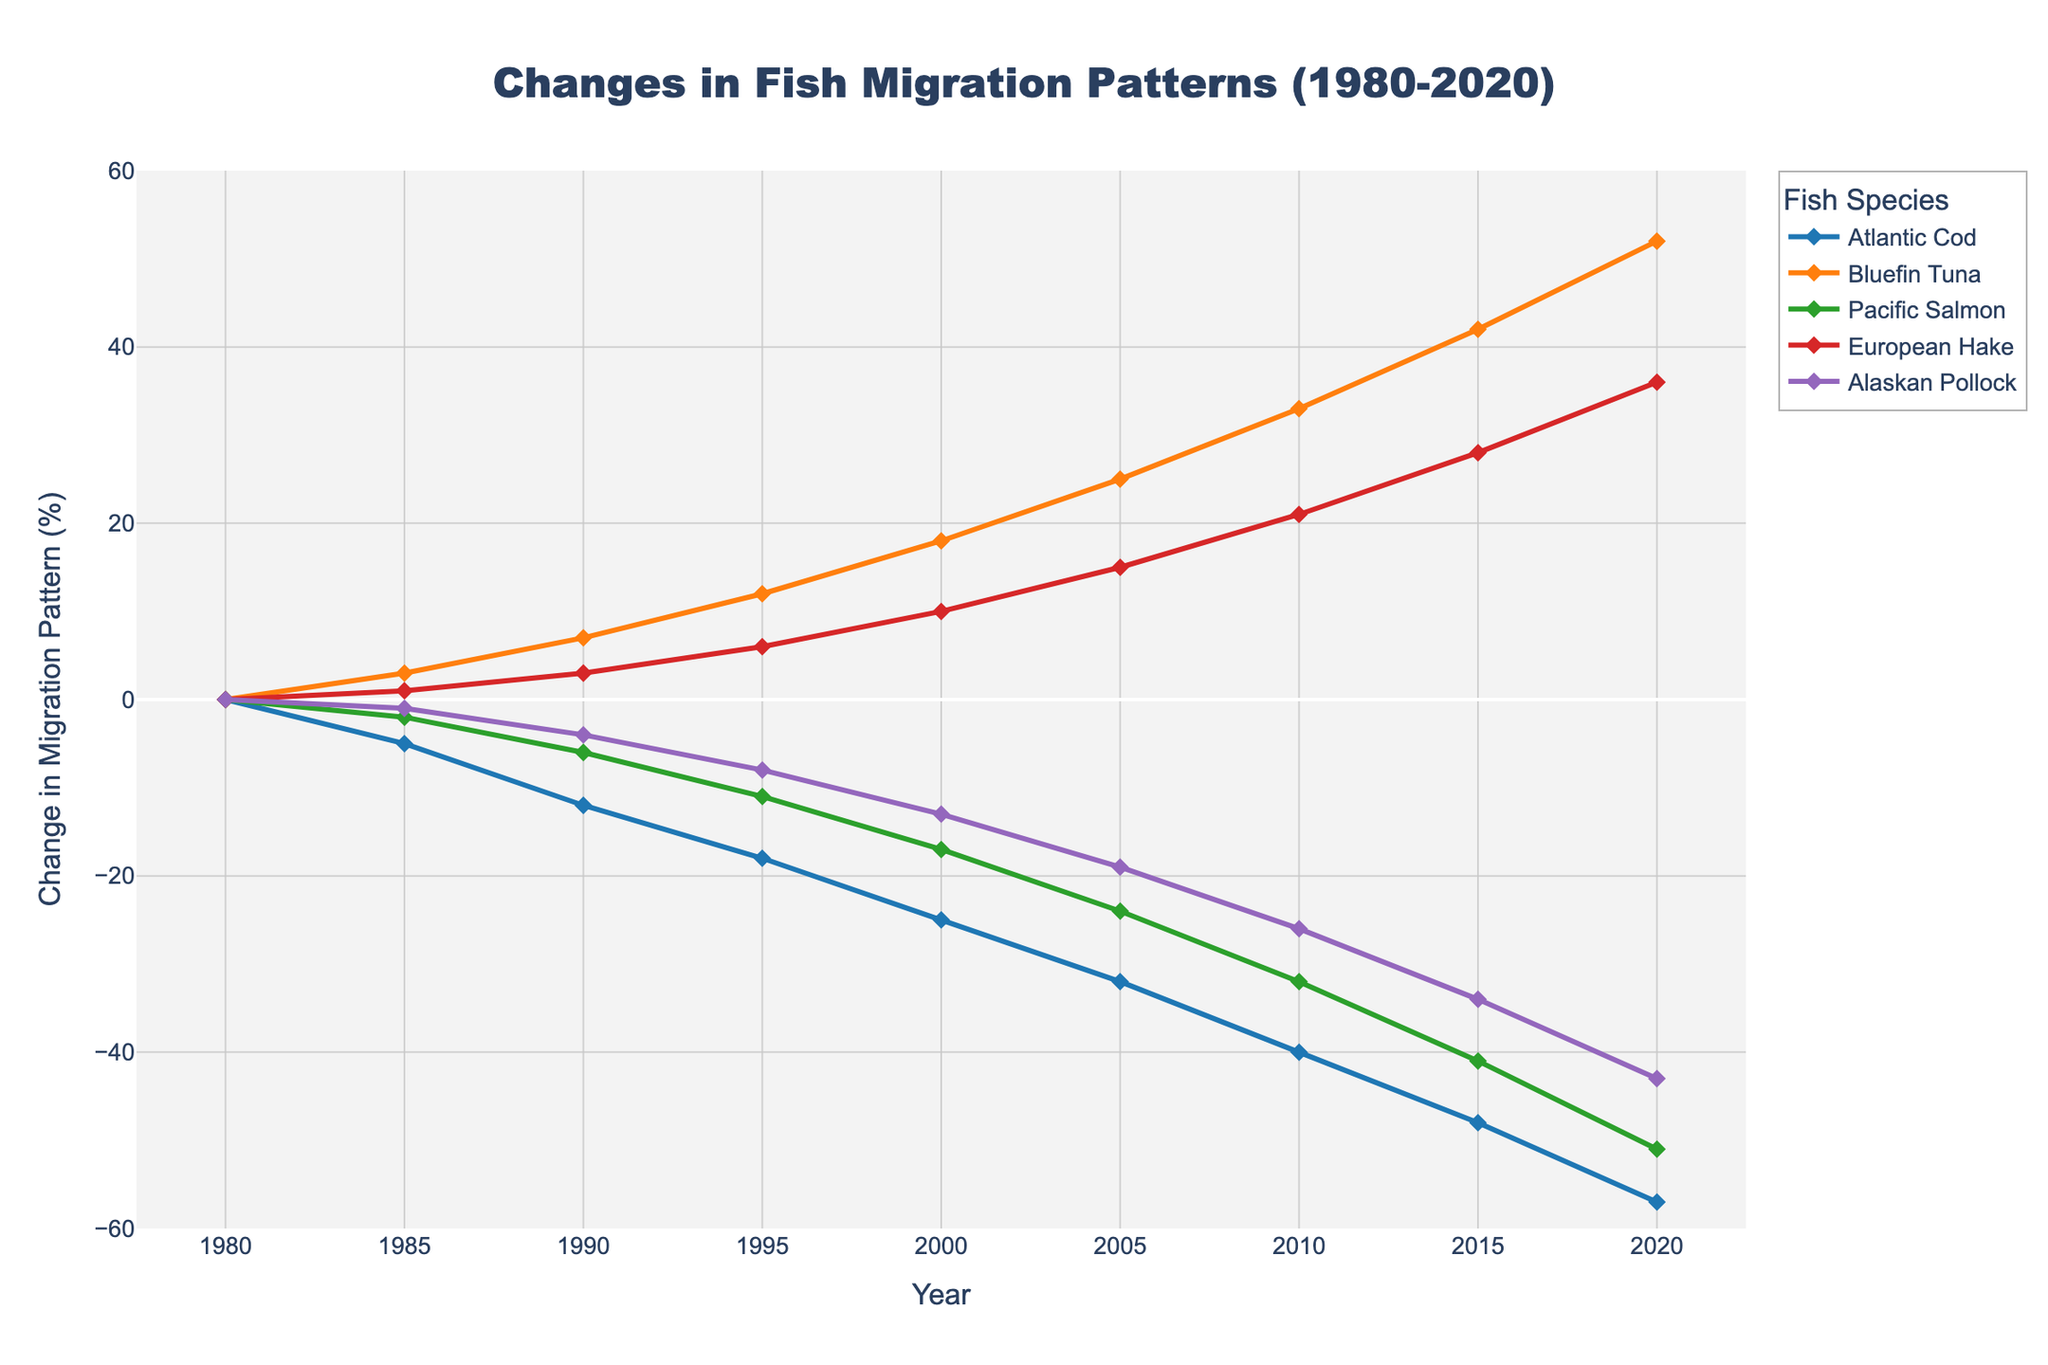Which fish species shows the greatest increase in migration pattern change from 1980 to 2020? Compare the data points of all species in 1980 and 2020. Bluefin Tuna changes from 0 in 1980 to 52 in 2020, which is the highest change.
Answer: Bluefin Tuna By how much did the migration pattern change for Atlantic Cod between 1985 and 2010? Find the data points for Atlantic Cod in 1985 and 2010 (-5 and -40) and subtract them. -40 - (-5) = -35.
Answer: -35 Which species experienced the smallest migration pattern change in 2000? Compare the values at the year 2000 for all species. Alaskan Pollock has the smallest change at -13.
Answer: Alaskan Pollock What was the average migration pattern change for Pacific Salmon from 1980 to 2000? Find the values for Pacific Salmon at each year, sum them up and divide by the number of years. Average = (0 - 2 - 6 - 11 - 17) / 5 = -36 / 5 = -7.2.
Answer: -7.2 Is there a year where Bluefin Tuna and European Hake had the same migration pattern change? Compare the values for Bluefin Tuna and European Hake across all years. In 1990, both have experienced changes of 7 and 3 respectively, which are different.
Answer: No Between 2005 and 2015, which species shows the largest change in migration patterns? Calculate the change for each species: Atlantic Cod (-32 to -48), Bluefin Tuna (25 to 42), Pacific Salmon (-24 to -41), European Hake (15 to 28), Alaskan Pollock (-19 to -34). Alaskan Pollock has the largest change, with -34 - (-19) = -15.
Answer: Alaskan Pollock Which species' migration pattern change remained negative throughout the years? Check all data points for each species to see if they are always negative. Atlantic Cod, Pacific Salmon, and Alaskan Pollock have all negative values.
Answer: Atlantic Cod, Pacific Salmon, Alaskan Pollock How many years did it take for Bluefin Tuna to have a change of 30 percent in migration pattern? Look for the year when Bluefin Tuna's migration pattern changed by 30 and refer to the initial year. It reached a change of 33 by 2010, so 30 is between 2005 and 2010.
Answer: 25 years 